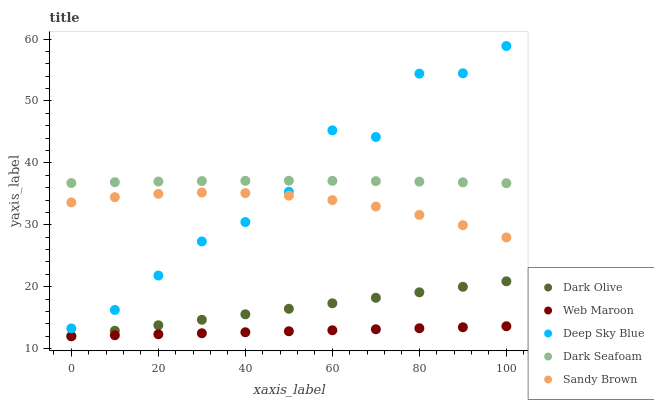Does Web Maroon have the minimum area under the curve?
Answer yes or no. Yes. Does Dark Seafoam have the maximum area under the curve?
Answer yes or no. Yes. Does Dark Olive have the minimum area under the curve?
Answer yes or no. No. Does Dark Olive have the maximum area under the curve?
Answer yes or no. No. Is Web Maroon the smoothest?
Answer yes or no. Yes. Is Deep Sky Blue the roughest?
Answer yes or no. Yes. Is Dark Seafoam the smoothest?
Answer yes or no. No. Is Dark Seafoam the roughest?
Answer yes or no. No. Does Dark Olive have the lowest value?
Answer yes or no. Yes. Does Dark Seafoam have the lowest value?
Answer yes or no. No. Does Deep Sky Blue have the highest value?
Answer yes or no. Yes. Does Dark Seafoam have the highest value?
Answer yes or no. No. Is Web Maroon less than Sandy Brown?
Answer yes or no. Yes. Is Sandy Brown greater than Web Maroon?
Answer yes or no. Yes. Does Web Maroon intersect Dark Olive?
Answer yes or no. Yes. Is Web Maroon less than Dark Olive?
Answer yes or no. No. Is Web Maroon greater than Dark Olive?
Answer yes or no. No. Does Web Maroon intersect Sandy Brown?
Answer yes or no. No. 